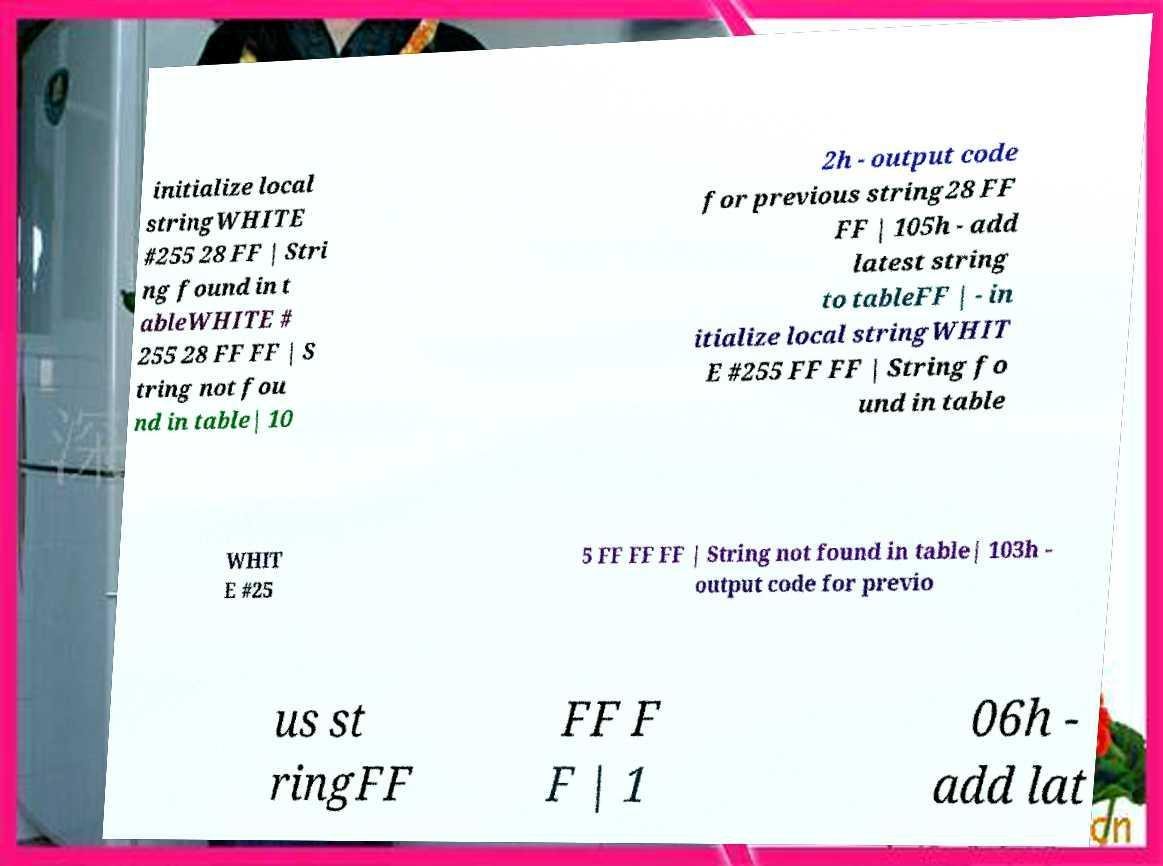Could you extract and type out the text from this image? initialize local stringWHITE #255 28 FF | Stri ng found in t ableWHITE # 255 28 FF FF | S tring not fou nd in table| 10 2h - output code for previous string28 FF FF | 105h - add latest string to tableFF | - in itialize local stringWHIT E #255 FF FF | String fo und in table WHIT E #25 5 FF FF FF | String not found in table| 103h - output code for previo us st ringFF FF F F | 1 06h - add lat 